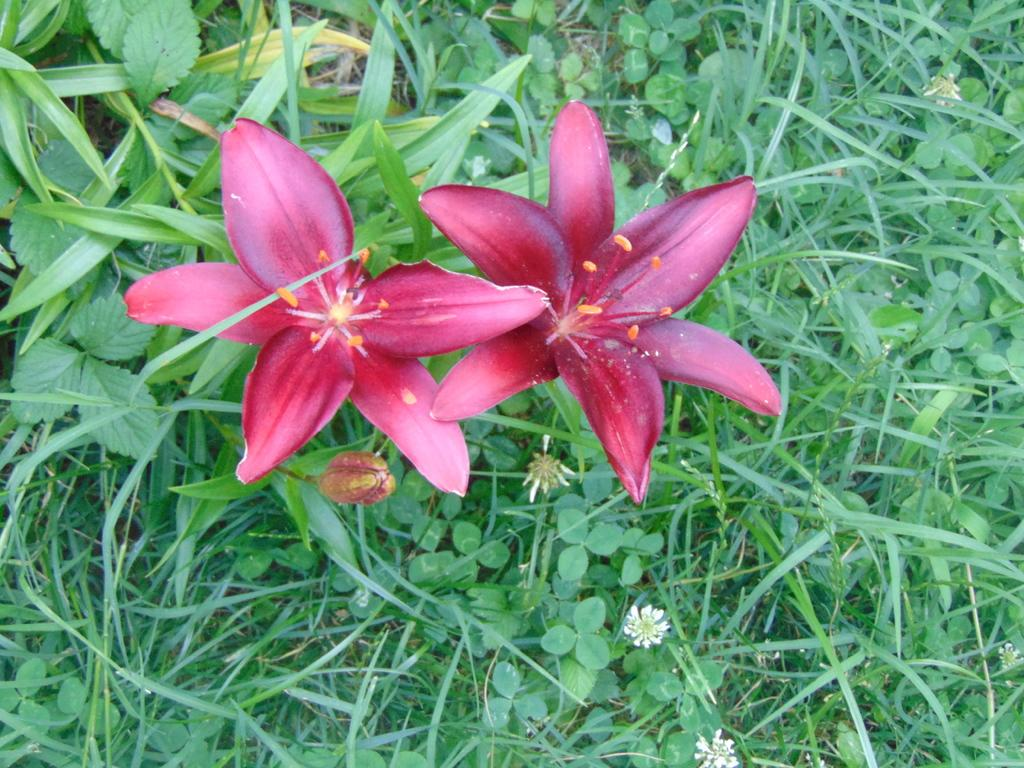What type of plants can be seen in the image? There are flowers in the image. What type of vegetation is present in the image besides flowers? There is grass visible in the image. Where is the mailbox located in the image? There is no mailbox present in the image. What type of credit can be seen on the flowers in the image? There is no credit associated with the flowers in the image. 